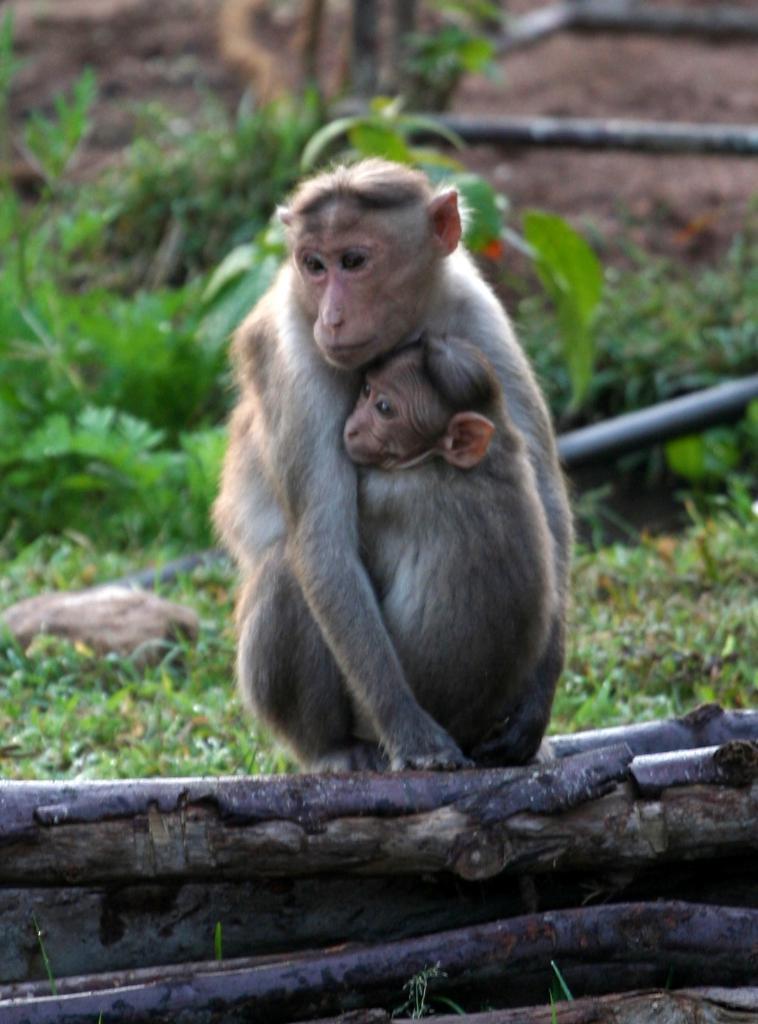In one or two sentences, can you explain what this image depicts? In this image I can see two monkeys which are brown and pink in color are hugging each other and sitting on a wooden log. In the background I can see some grass, a rock, few pants , few black colored pipes and the ground. 